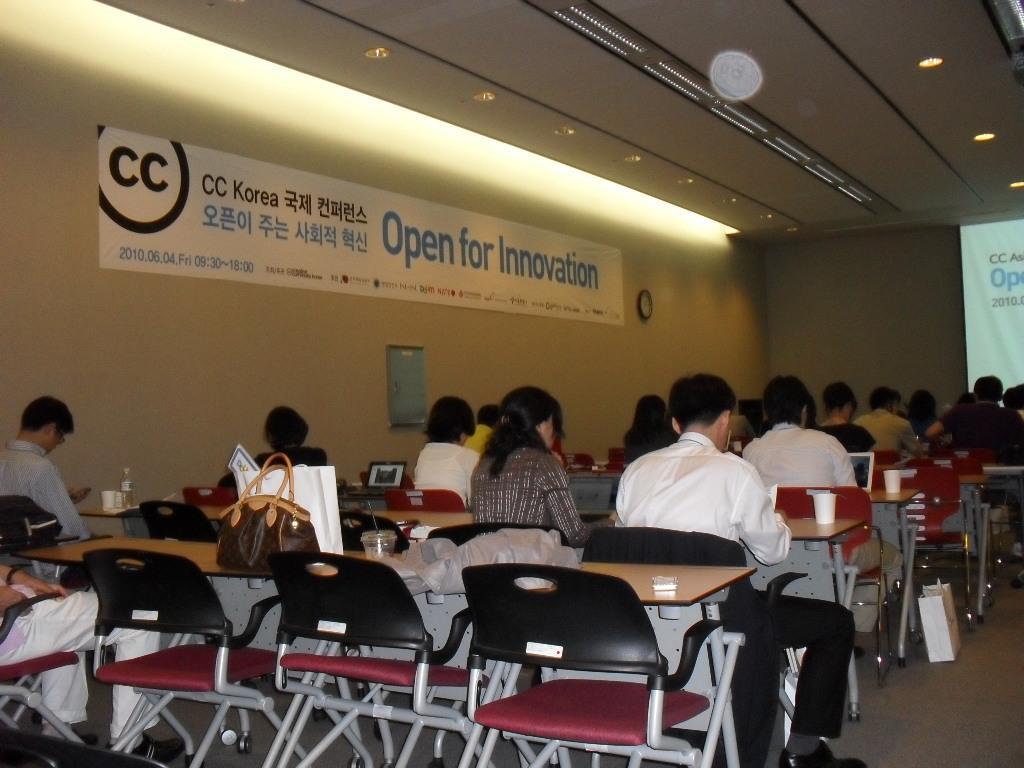Could you give a brief overview of what you see in this image? There are people sitting in chairs at tables. There is a screen in front of them. There is flex with a title open for innovation on it. 